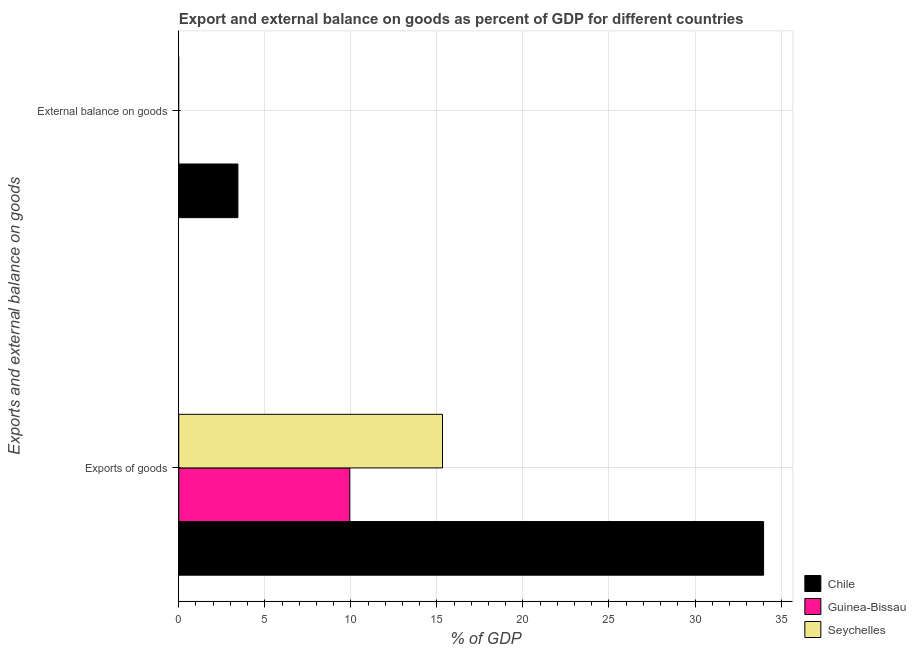How many different coloured bars are there?
Your response must be concise. 3. How many bars are there on the 1st tick from the bottom?
Offer a very short reply. 3. What is the label of the 2nd group of bars from the top?
Your answer should be compact. Exports of goods. What is the export of goods as percentage of gdp in Chile?
Your answer should be compact. 33.99. Across all countries, what is the maximum export of goods as percentage of gdp?
Give a very brief answer. 33.99. What is the total external balance on goods as percentage of gdp in the graph?
Make the answer very short. 3.44. What is the difference between the export of goods as percentage of gdp in Chile and that in Guinea-Bissau?
Provide a short and direct response. 24.05. What is the difference between the export of goods as percentage of gdp in Guinea-Bissau and the external balance on goods as percentage of gdp in Chile?
Keep it short and to the point. 6.5. What is the average export of goods as percentage of gdp per country?
Ensure brevity in your answer.  19.75. What is the difference between the external balance on goods as percentage of gdp and export of goods as percentage of gdp in Chile?
Your response must be concise. -30.55. In how many countries, is the external balance on goods as percentage of gdp greater than 34 %?
Give a very brief answer. 0. What is the ratio of the export of goods as percentage of gdp in Chile to that in Guinea-Bissau?
Your response must be concise. 3.42. What is the difference between two consecutive major ticks on the X-axis?
Give a very brief answer. 5. Does the graph contain grids?
Give a very brief answer. Yes. What is the title of the graph?
Keep it short and to the point. Export and external balance on goods as percent of GDP for different countries. What is the label or title of the X-axis?
Provide a succinct answer. % of GDP. What is the label or title of the Y-axis?
Make the answer very short. Exports and external balance on goods. What is the % of GDP of Chile in Exports of goods?
Offer a very short reply. 33.99. What is the % of GDP in Guinea-Bissau in Exports of goods?
Provide a short and direct response. 9.94. What is the % of GDP of Seychelles in Exports of goods?
Keep it short and to the point. 15.33. What is the % of GDP of Chile in External balance on goods?
Your response must be concise. 3.44. What is the % of GDP in Guinea-Bissau in External balance on goods?
Your answer should be compact. 0. Across all Exports and external balance on goods, what is the maximum % of GDP in Chile?
Offer a terse response. 33.99. Across all Exports and external balance on goods, what is the maximum % of GDP of Guinea-Bissau?
Your answer should be very brief. 9.94. Across all Exports and external balance on goods, what is the maximum % of GDP in Seychelles?
Offer a terse response. 15.33. Across all Exports and external balance on goods, what is the minimum % of GDP in Chile?
Make the answer very short. 3.44. What is the total % of GDP of Chile in the graph?
Keep it short and to the point. 37.42. What is the total % of GDP in Guinea-Bissau in the graph?
Ensure brevity in your answer.  9.94. What is the total % of GDP of Seychelles in the graph?
Offer a very short reply. 15.33. What is the difference between the % of GDP in Chile in Exports of goods and that in External balance on goods?
Offer a very short reply. 30.55. What is the average % of GDP in Chile per Exports and external balance on goods?
Ensure brevity in your answer.  18.71. What is the average % of GDP of Guinea-Bissau per Exports and external balance on goods?
Ensure brevity in your answer.  4.97. What is the average % of GDP of Seychelles per Exports and external balance on goods?
Provide a succinct answer. 7.66. What is the difference between the % of GDP of Chile and % of GDP of Guinea-Bissau in Exports of goods?
Your answer should be very brief. 24.05. What is the difference between the % of GDP in Chile and % of GDP in Seychelles in Exports of goods?
Keep it short and to the point. 18.66. What is the difference between the % of GDP of Guinea-Bissau and % of GDP of Seychelles in Exports of goods?
Your answer should be very brief. -5.39. What is the ratio of the % of GDP of Chile in Exports of goods to that in External balance on goods?
Make the answer very short. 9.89. What is the difference between the highest and the second highest % of GDP in Chile?
Offer a terse response. 30.55. What is the difference between the highest and the lowest % of GDP in Chile?
Offer a very short reply. 30.55. What is the difference between the highest and the lowest % of GDP of Guinea-Bissau?
Offer a terse response. 9.94. What is the difference between the highest and the lowest % of GDP of Seychelles?
Your answer should be very brief. 15.33. 